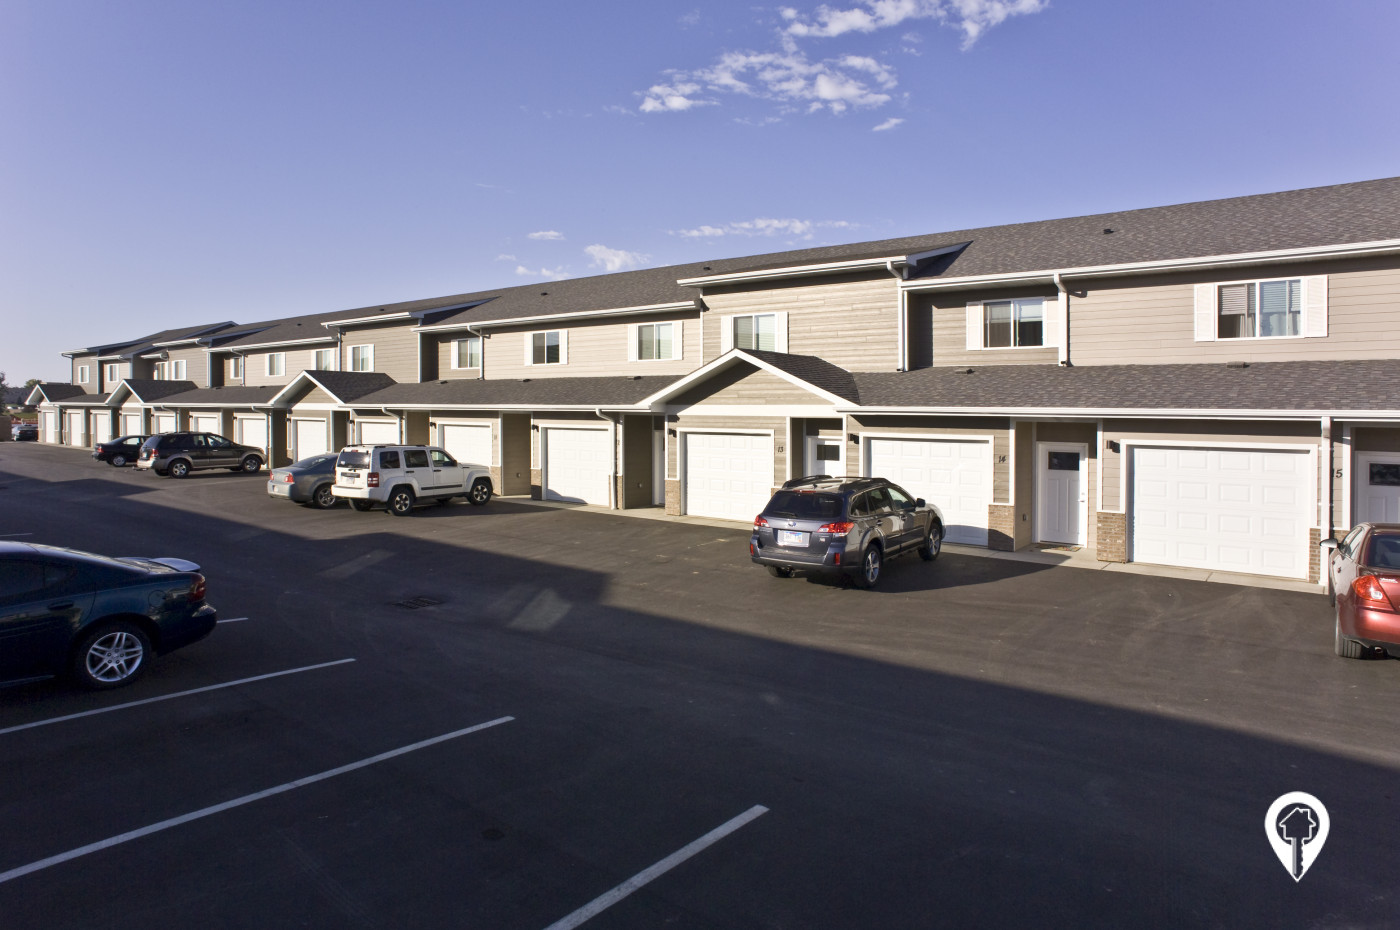What types of cars are parked in the lot, and what might that say about the residents? The parking lot features a variety of cars including compact sedans, SUVs, and a pickup truck. This diversity suggests that the residents might come from various walks of life, reflecting a wide range of family sizes and personal preferences. Such a mix could imply a suburban area where residents use their cars for different purposes, like commuting, family trips, or even work-related utilities like the pickup truck. 